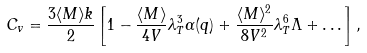<formula> <loc_0><loc_0><loc_500><loc_500>C _ { v } = \frac { 3 \langle M \rangle k } { 2 } \left [ 1 - \frac { \langle M \rangle } { 4 V } \lambda _ { T } ^ { 3 } \alpha ( q ) + \frac { \langle M \rangle ^ { 2 } } { 8 V ^ { 2 } } \lambda _ { T } ^ { 6 } \Lambda + \dots \right ] ,</formula> 